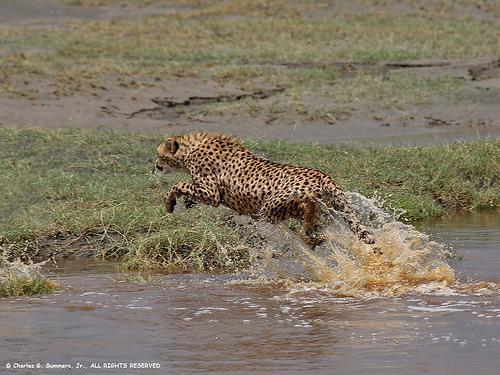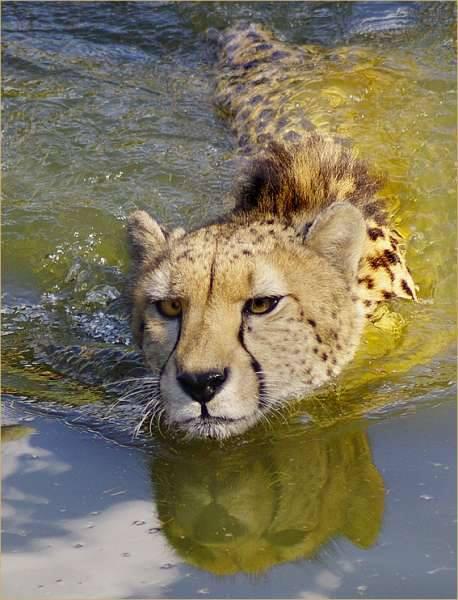The first image is the image on the left, the second image is the image on the right. For the images displayed, is the sentence "The left image has a cheetah that is approaching the shore." factually correct? Answer yes or no. Yes. 